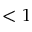Convert formula to latex. <formula><loc_0><loc_0><loc_500><loc_500>< 1</formula> 